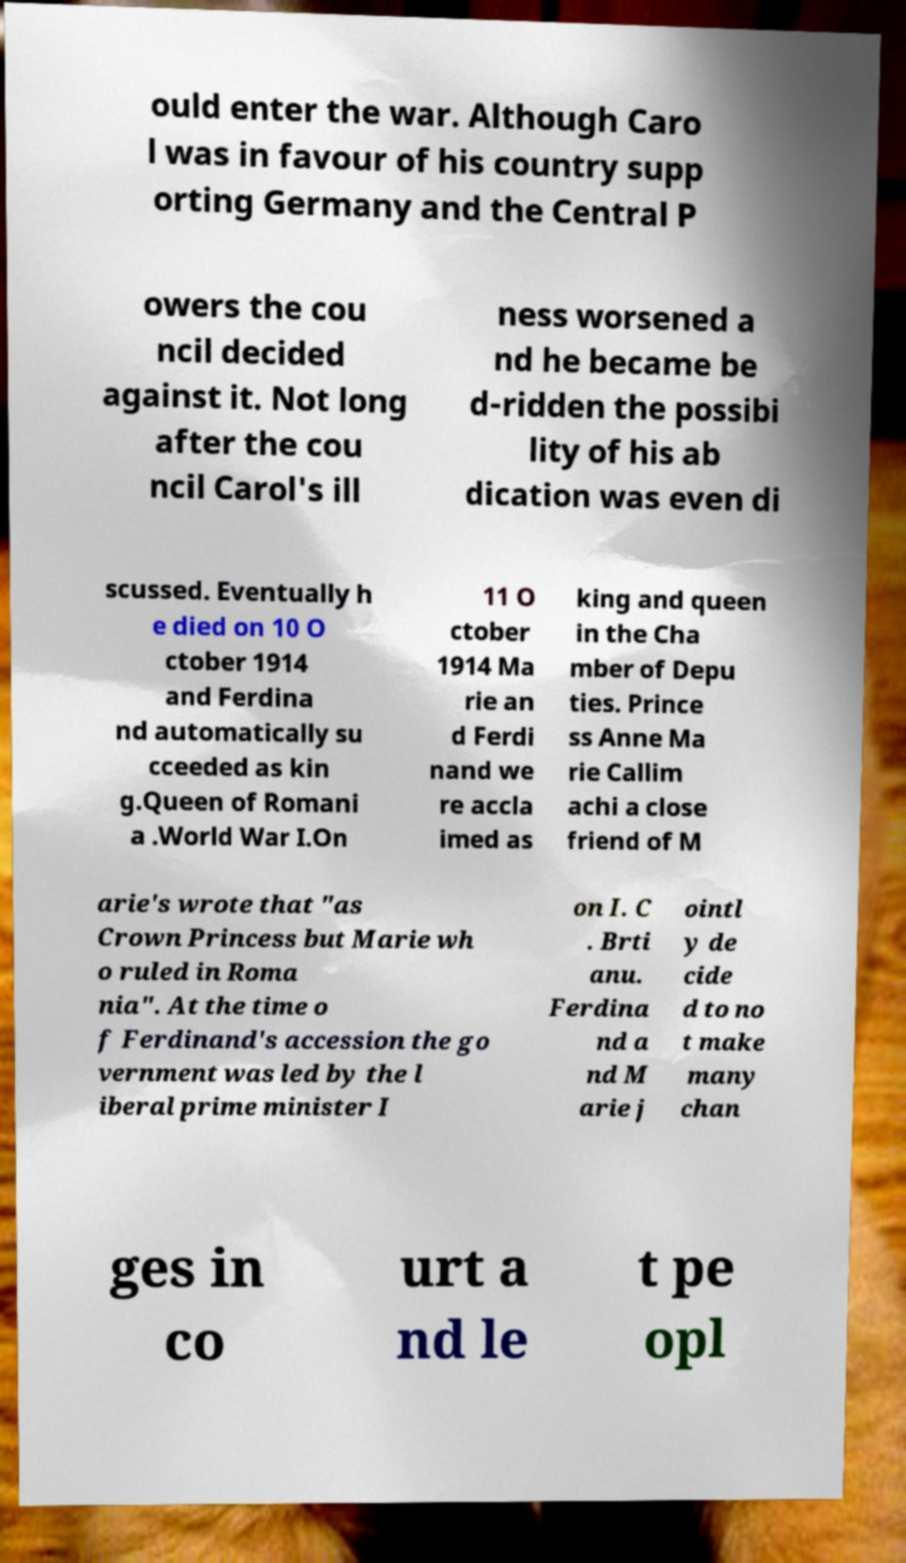Could you extract and type out the text from this image? ould enter the war. Although Caro l was in favour of his country supp orting Germany and the Central P owers the cou ncil decided against it. Not long after the cou ncil Carol's ill ness worsened a nd he became be d-ridden the possibi lity of his ab dication was even di scussed. Eventually h e died on 10 O ctober 1914 and Ferdina nd automatically su cceeded as kin g.Queen of Romani a .World War I.On 11 O ctober 1914 Ma rie an d Ferdi nand we re accla imed as king and queen in the Cha mber of Depu ties. Prince ss Anne Ma rie Callim achi a close friend of M arie's wrote that "as Crown Princess but Marie wh o ruled in Roma nia". At the time o f Ferdinand's accession the go vernment was led by the l iberal prime minister I on I. C . Brti anu. Ferdina nd a nd M arie j ointl y de cide d to no t make many chan ges in co urt a nd le t pe opl 